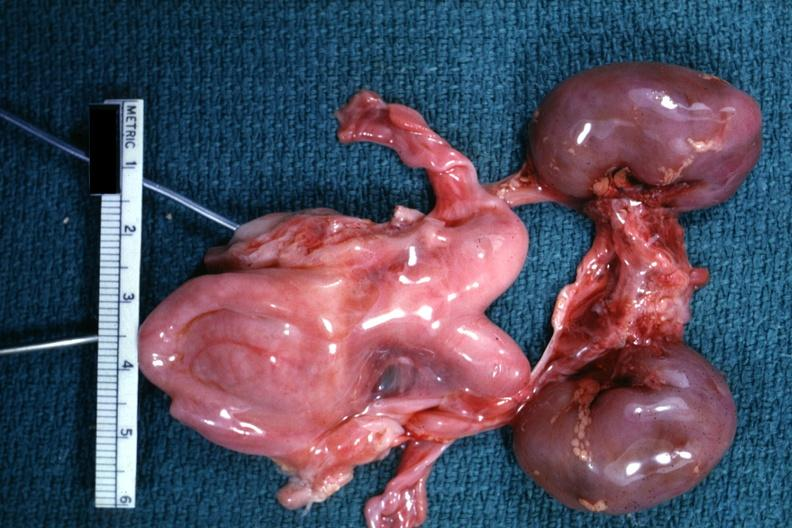does this image show infant organs clearly shown lesion?
Answer the question using a single word or phrase. Yes 